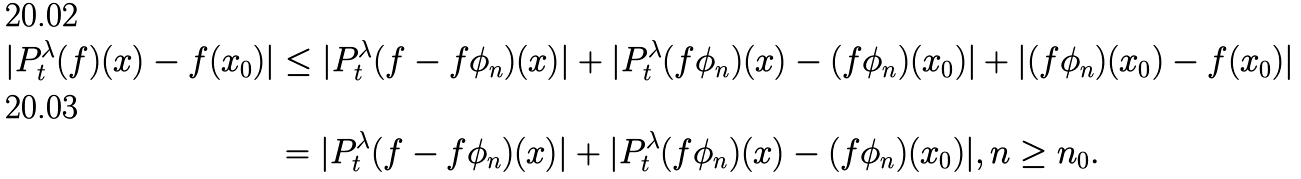Convert formula to latex. <formula><loc_0><loc_0><loc_500><loc_500>| P _ { t } ^ { \lambda } ( f ) ( x ) - f ( x _ { 0 } ) | & \leq | P _ { t } ^ { \lambda } ( f - f \phi _ { n } ) ( x ) | + | P _ { t } ^ { \lambda } ( f \phi _ { n } ) ( x ) - ( f \phi _ { n } ) ( x _ { 0 } ) | + | ( f \phi _ { n } ) ( x _ { 0 } ) - f ( x _ { 0 } ) | \\ & = | P _ { t } ^ { \lambda } ( f - f \phi _ { n } ) ( x ) | + | P _ { t } ^ { \lambda } ( f \phi _ { n } ) ( x ) - ( f \phi _ { n } ) ( x _ { 0 } ) | , n \geq n _ { 0 } .</formula> 